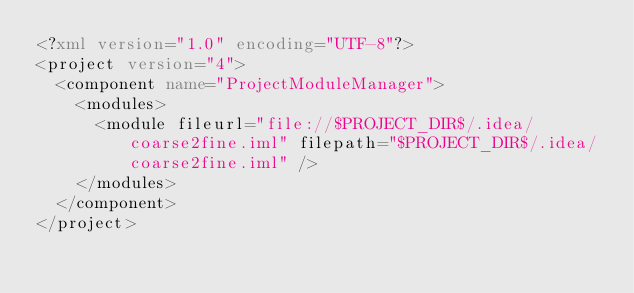Convert code to text. <code><loc_0><loc_0><loc_500><loc_500><_XML_><?xml version="1.0" encoding="UTF-8"?>
<project version="4">
  <component name="ProjectModuleManager">
    <modules>
      <module fileurl="file://$PROJECT_DIR$/.idea/coarse2fine.iml" filepath="$PROJECT_DIR$/.idea/coarse2fine.iml" />
    </modules>
  </component>
</project></code> 